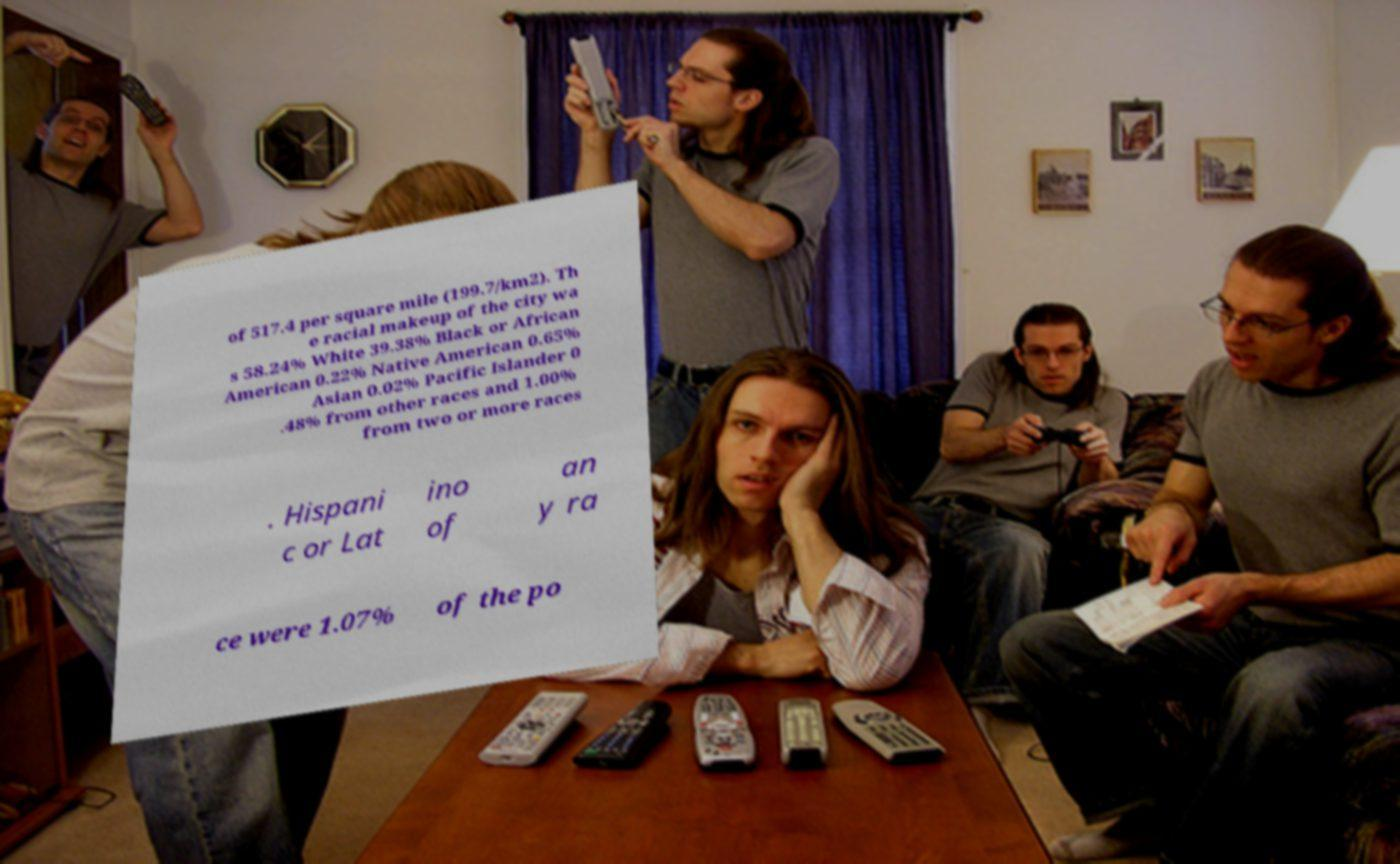Please identify and transcribe the text found in this image. of 517.4 per square mile (199.7/km2). Th e racial makeup of the city wa s 58.24% White 39.38% Black or African American 0.22% Native American 0.65% Asian 0.02% Pacific Islander 0 .48% from other races and 1.00% from two or more races . Hispani c or Lat ino of an y ra ce were 1.07% of the po 